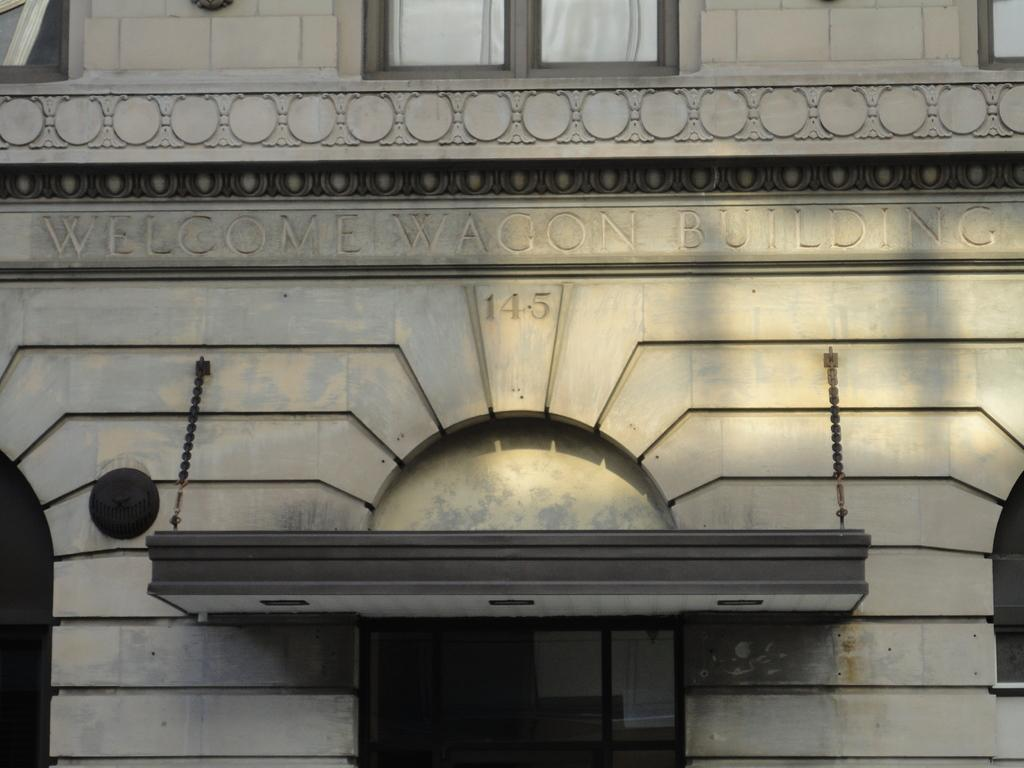What is the main subject of the picture? The main subject of the picture is a building. What can be seen on the wall of the building? There is text on the wall of the building. Can you identify any specific details in the image? Yes, there is a number visible in the image. What is the tendency of the trees in the image? There are no trees present in the image, so it is not possible to determine their tendency. 